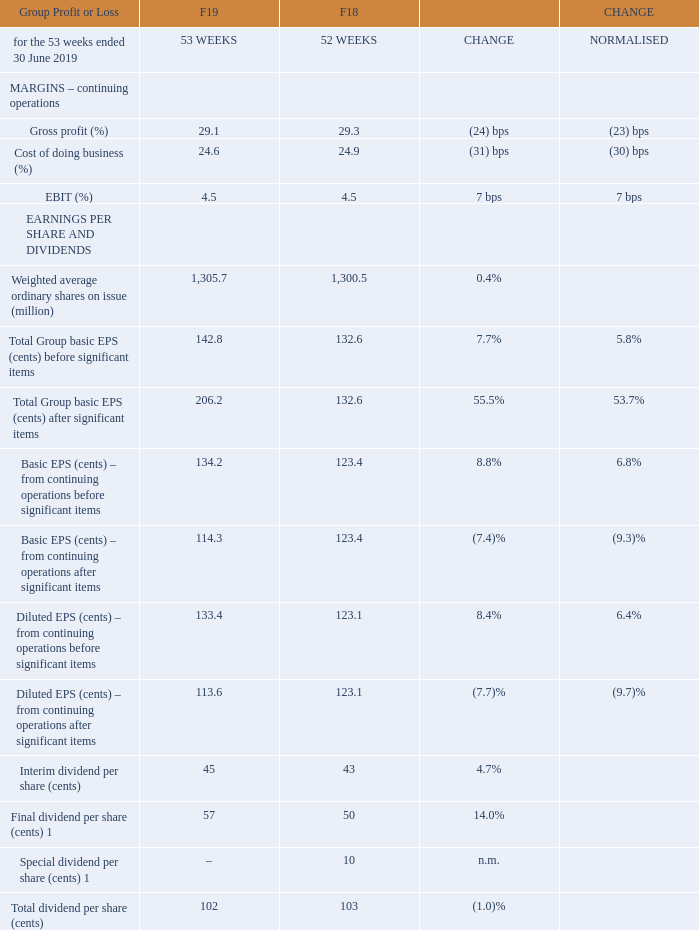Central Overheads declined by $76 million in F19 to $60 million due to a one‐off payment from Caltex of $50 million and a reversal of impairment on a property subsequently classified as held for sale of $37 million. Central Overheads are still expected to be approximately $150 million on an annual basis before taking into account any impact from the Endeavour Group transaction.
A small increase in inventory to $4,280 million was primarily due to higher closing inventory in New Zealand and BIG W to improve availability. Closing inventory days declined 0.9 days to 37.2 days and average inventory days from continuing operations declined by 0.2 days to 38.8 days.
Net investment in inventory of $939 million remained broadly consistent with prior year. Adjusting for the impact of an extra New Zealand Food payment run in the 53rd week of $153 million, net investment in inventory declined by 19%.
Other creditors and provisions of $4,308 million decreased $40 million compared to the prior year. Excluding significant items relating to the BIG W network review and cash utilisation of F16 significant items provisions, the decrease in other creditors and provisions was primarily driven by a reduction in accruals associated with store team costs.
Fixed assets, investments and loans to related parties of $9,710 million increased by $528 million. Additions of fixed assets of $2,040 million during the year mainly related to store refurbishments, supply chain and IT infrastructure and included $203 million related to property development activity. This was partially offset by depreciation and amortisation, disposals and an impairment of $166 million associated with the BIG W network review.
Net assets held for sale of $225 million decreased by $575 million mainly as a result of the sale of the Petrol business to EG Group on 1 April 2019.
Intangible assets of $6,526 million increased by $61 million driven by an increase in goodwill and brand names in New Zealand due to the strengthening of the New Zealand dollar, a minor increase in goodwill associated with the acquisition of businesses partially offset by an impairment to the carrying value of Summergate of $21 million.
Net tax balances of $227 million increased $66 million due to an increase in deferred tax assets associated with the provisions raised as a result of the BIG W network review.
Net debt of $1,599 million increased by $377 million largely due to the timing of New Zealand creditor payments, higher net capital expenditure (excluding the proceeds from the sale of the Petrol business) and an increase in dividends paid during the year.
Normalised Return on Funds Employed (ROFE) from continuing operations was 24.2%, 11 bps up on the prior year. Normalised AASB 16 estimated ROFE was 14.1%.
Cash flow from operating activities before interest and tax was $3,858 million, an increase of 0.5% on the prior year. Excluding the impact of significant items, higher EBITDA was offset by the impact of the New Zealand payment run in week 53 and a movement in provisions and accruals. The cash flow benefit from an extra week of trading is offset by nine months of EBITDA from the Petrol business compared to a full year in F18.
The cash realisation ratio was 74.1%. Excluding the timing of the New Zealand payment run, and charges associated with the BIG W network review and gain on sale of the Petrol business, the cash realisation ratio was 98.4%, impacted by the cash utilisation of provisions and accruals offset by trade working capital improvements.
Net interest paid of $166 million declined by 9.8% compared to the prior year due to the early repayment of US Private Placement Notes in the prior year reducing average borrowing costs.
What is the value of Central Overheads in F19? $60 million. What is the total dividend per share in F19? 102. What is the EBIT for F19?
Answer scale should be: percent. 4.5. What percentage of the total dividend per share does the interim dividend per share constitute?
Answer scale should be: percent. 45/102 
Answer: 44.12. What is the nominal difference of the total group basic EPS (cents) before significant items and after significant items? 206.2-142.8 
Answer: 63.4. What is the value of Central Overheads in F18?
Answer scale should be: million. 76 + 60 
Answer: 136. 